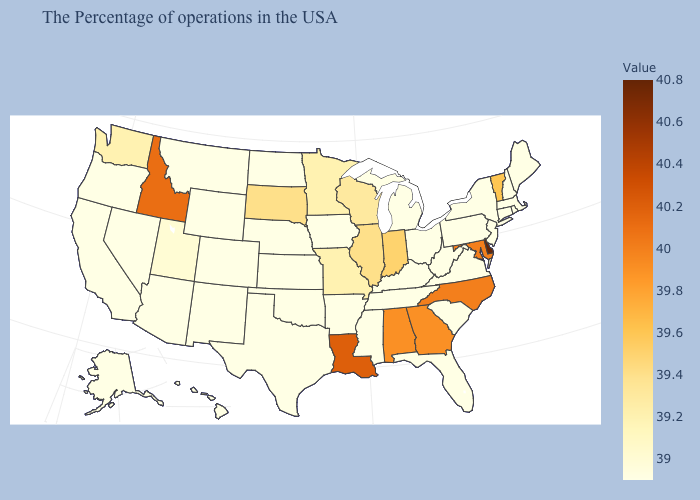Which states hav the highest value in the MidWest?
Short answer required. Indiana. Does Missouri have the lowest value in the USA?
Concise answer only. No. Does the map have missing data?
Quick response, please. No. Among the states that border South Carolina , which have the lowest value?
Quick response, please. Georgia. Does the map have missing data?
Write a very short answer. No. Does New York have the lowest value in the Northeast?
Quick response, please. Yes. Which states have the lowest value in the Northeast?
Answer briefly. Maine, Massachusetts, Rhode Island, New Hampshire, Connecticut, New York, New Jersey, Pennsylvania. 